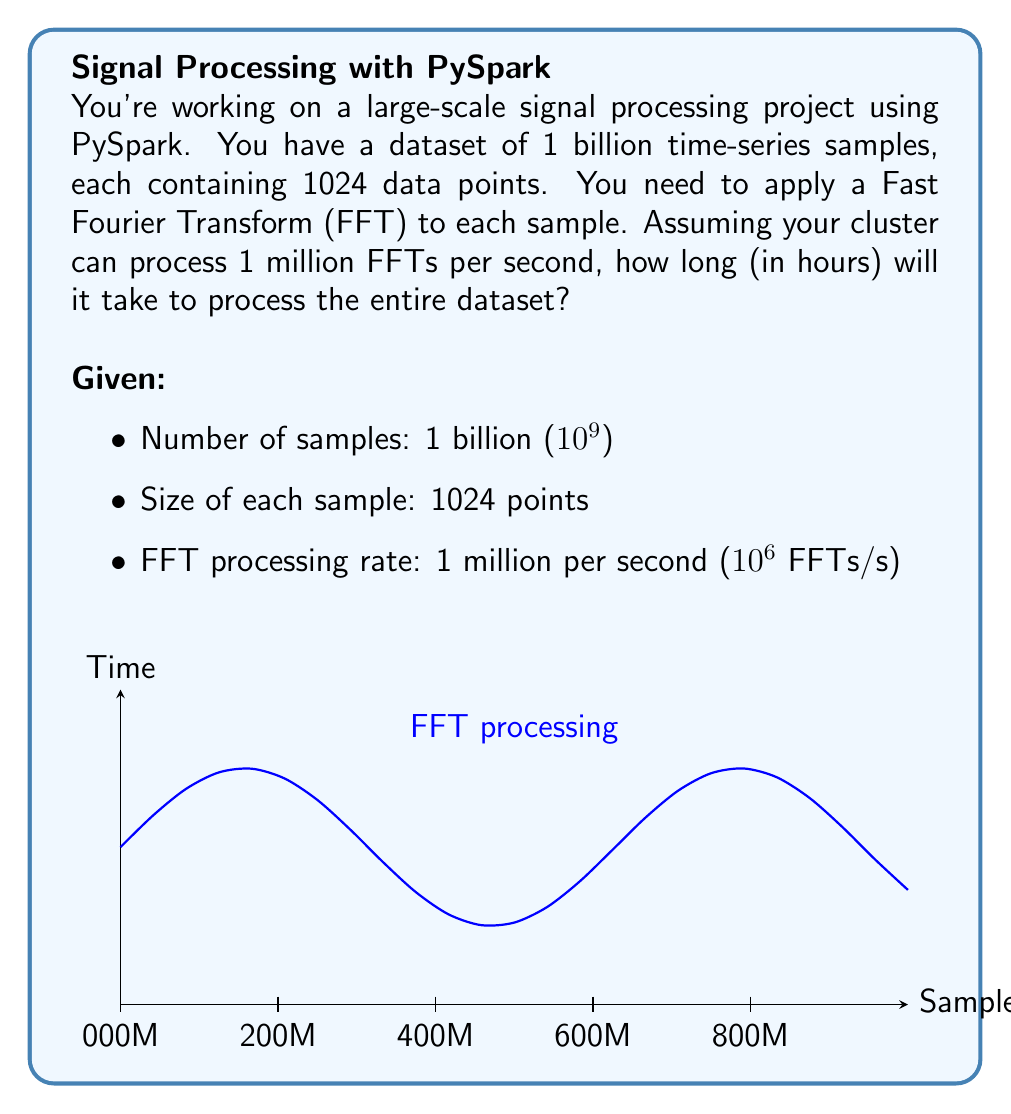Can you answer this question? Let's approach this step-by-step:

1) First, we need to calculate the total number of FFTs we need to perform:
   $$\text{Total FFTs} = 10^9 \text{ samples}$$

2) Now, let's calculate how many FFTs can be processed per hour:
   $$\text{FFTs per hour} = 10^6 \text{ FFTs/s} \times 3600 \text{ s/hour} = 3.6 \times 10^9 \text{ FFTs/hour}$$

3) To find the time needed, we divide the total number of FFTs by the processing rate per hour:
   $$\text{Time (in hours)} = \frac{\text{Total FFTs}}{\text{FFTs per hour}} = \frac{10^9}{3.6 \times 10^9} = \frac{1}{3.6} \approx 0.2778 \text{ hours}$$

4) Converting to minutes for a more intuitive understanding:
   $$0.2778 \text{ hours} \times 60 \text{ minutes/hour} \approx 16.67 \text{ minutes}$$

Note: The size of each sample (1024 points) doesn't affect the calculation because the FFT processing rate is given per sample, not per data point. In a real-world scenario, the sample size would affect the processing time, but for this problem, we assume the given rate accounts for the sample size.

This result demonstrates the power of distributed computing using frameworks like PySpark for processing large-scale datasets efficiently.
Answer: 0.2778 hours 